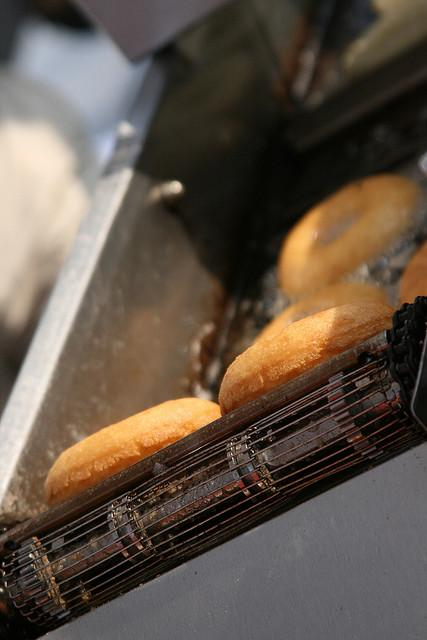What step of donut creation is this scene at? frying 